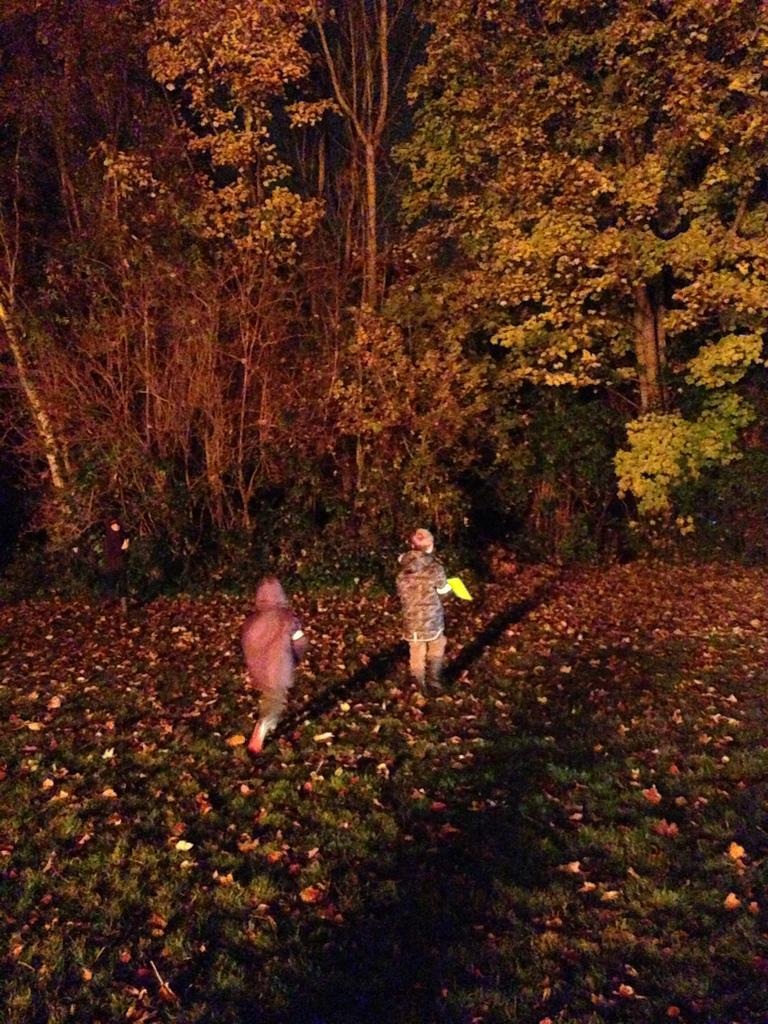What type of vegetation is present in the image? There are many trees in the image. What is the condition of the leaves on the trees? There are many dry leaves in the image. What type of terrain is visible in the image? There is a grassy land in the image. How many people can be seen in the image? There are two persons in the image. What type of jelly can be seen on the trees in the image? There is no jelly present on the trees in the image; it is dry leaves that are visible. 